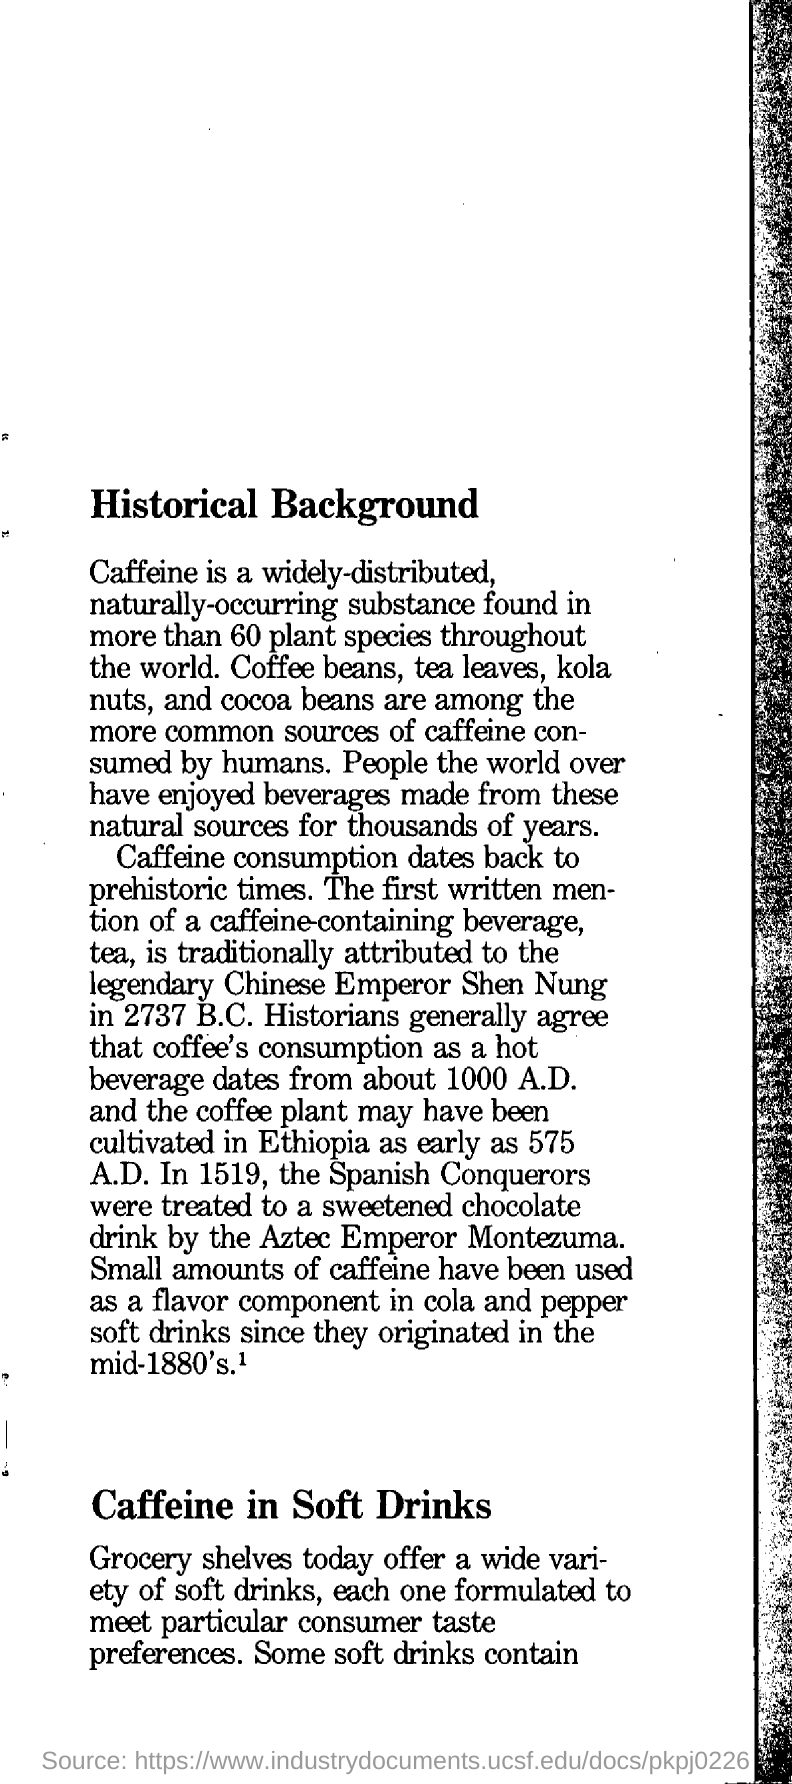Identify some key points in this picture. Caffeine, a commonly consumed stimulant, is obtained from various sources, including coffee beans, tea leaves, kola nuts, and cocoa beans. The first written mention of a coffee-containing beverage is traditionally attributed to Shen Nung, who is considered the legendary discoverer of tea. The title of the page is 'Historical Background,' which provides a comprehensive overview of a particular subject or event in history. Caffeine is a widely distributed, naturally occurring substance that can be found in more than 60 plant species throughout the world. Montezuma, the Aztec emperor, treated Spanish conquerors to a sweetened chocolate drink. 